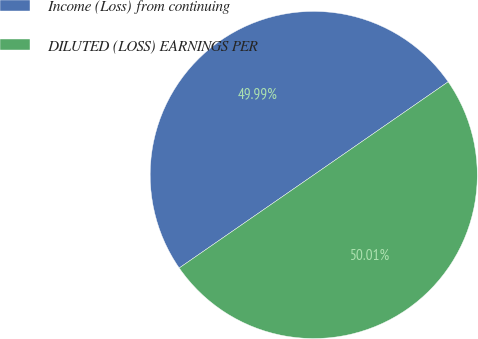Convert chart to OTSL. <chart><loc_0><loc_0><loc_500><loc_500><pie_chart><fcel>Income (Loss) from continuing<fcel>DILUTED (LOSS) EARNINGS PER<nl><fcel>49.99%<fcel>50.01%<nl></chart> 